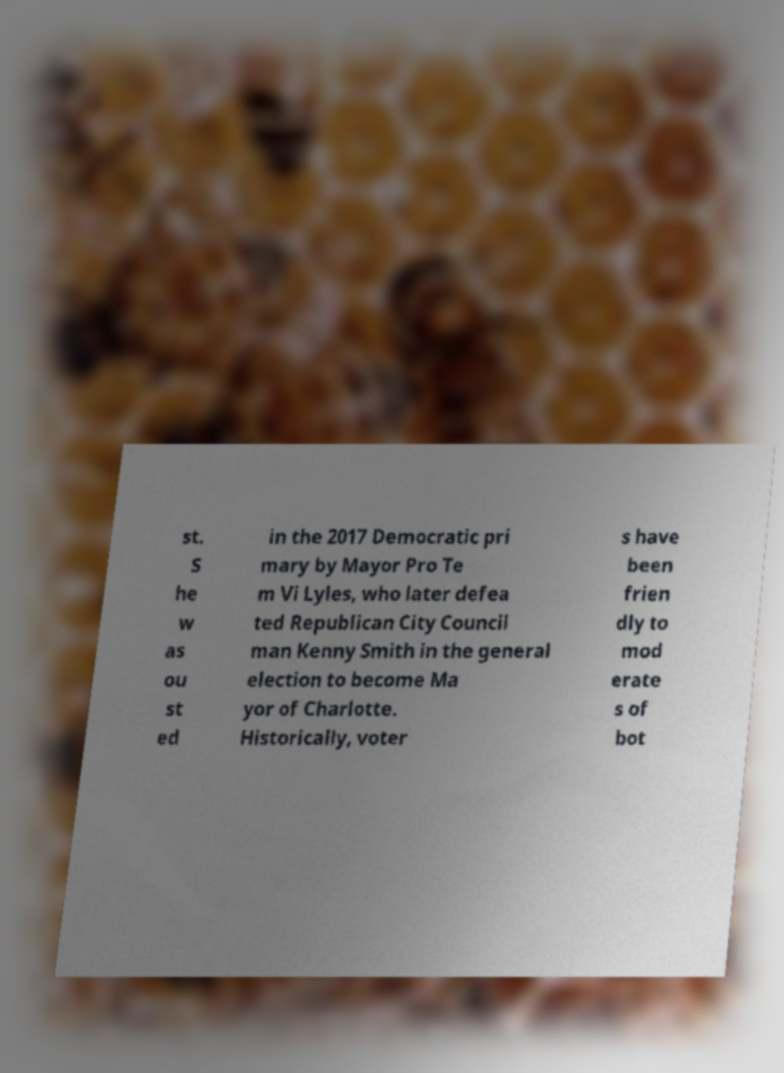For documentation purposes, I need the text within this image transcribed. Could you provide that? st. S he w as ou st ed in the 2017 Democratic pri mary by Mayor Pro Te m Vi Lyles, who later defea ted Republican City Council man Kenny Smith in the general election to become Ma yor of Charlotte. Historically, voter s have been frien dly to mod erate s of bot 